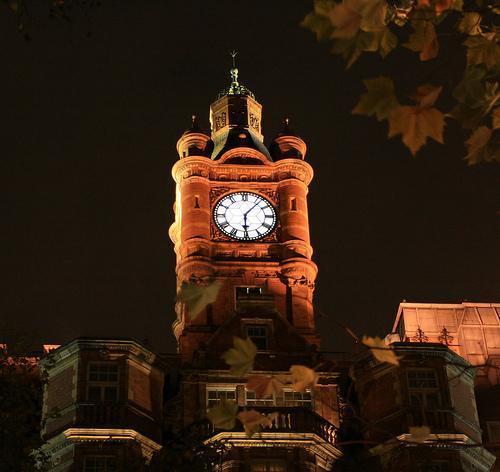How many towers are there?
Give a very brief answer. 1. 